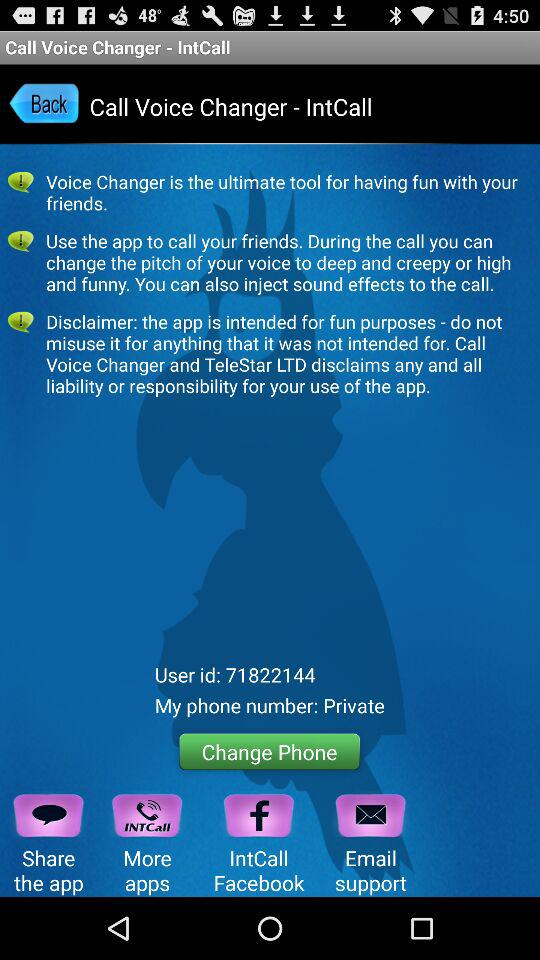What is the user ID? The user ID is 71822144. 